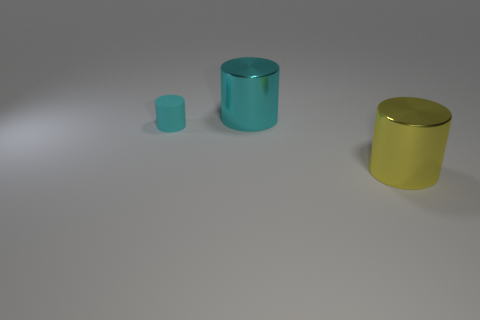How many objects are either big metallic things to the left of the large yellow metal cylinder or small brown blocks?
Offer a very short reply. 1. What number of big cyan things are made of the same material as the tiny cyan cylinder?
Ensure brevity in your answer.  0. The other large thing that is the same color as the rubber object is what shape?
Your answer should be very brief. Cylinder. Is the number of large yellow metallic cylinders that are to the left of the big cyan thing the same as the number of large red matte balls?
Your response must be concise. Yes. How big is the shiny cylinder that is in front of the small cyan object?
Provide a short and direct response. Large. How many big objects are cyan shiny cylinders or metallic objects?
Offer a very short reply. 2. There is another big metal thing that is the same shape as the large cyan metallic thing; what is its color?
Ensure brevity in your answer.  Yellow. Is the size of the matte cylinder the same as the yellow object?
Provide a succinct answer. No. How many objects are either large brown rubber things or things that are to the right of the tiny cyan cylinder?
Your answer should be very brief. 2. There is a cylinder left of the shiny thing on the left side of the big yellow cylinder; what color is it?
Your answer should be very brief. Cyan. 